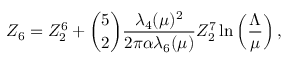Convert formula to latex. <formula><loc_0><loc_0><loc_500><loc_500>Z _ { 6 } = Z _ { 2 } ^ { 6 } + { \binom { 5 } { 2 } } { \frac { \lambda _ { 4 } ( \mu ) ^ { 2 } } { 2 \pi \alpha \lambda _ { 6 } ( \mu ) } } Z _ { 2 } ^ { 7 } \ln \left ( \frac { \Lambda } { \mu } \right ) ,</formula> 